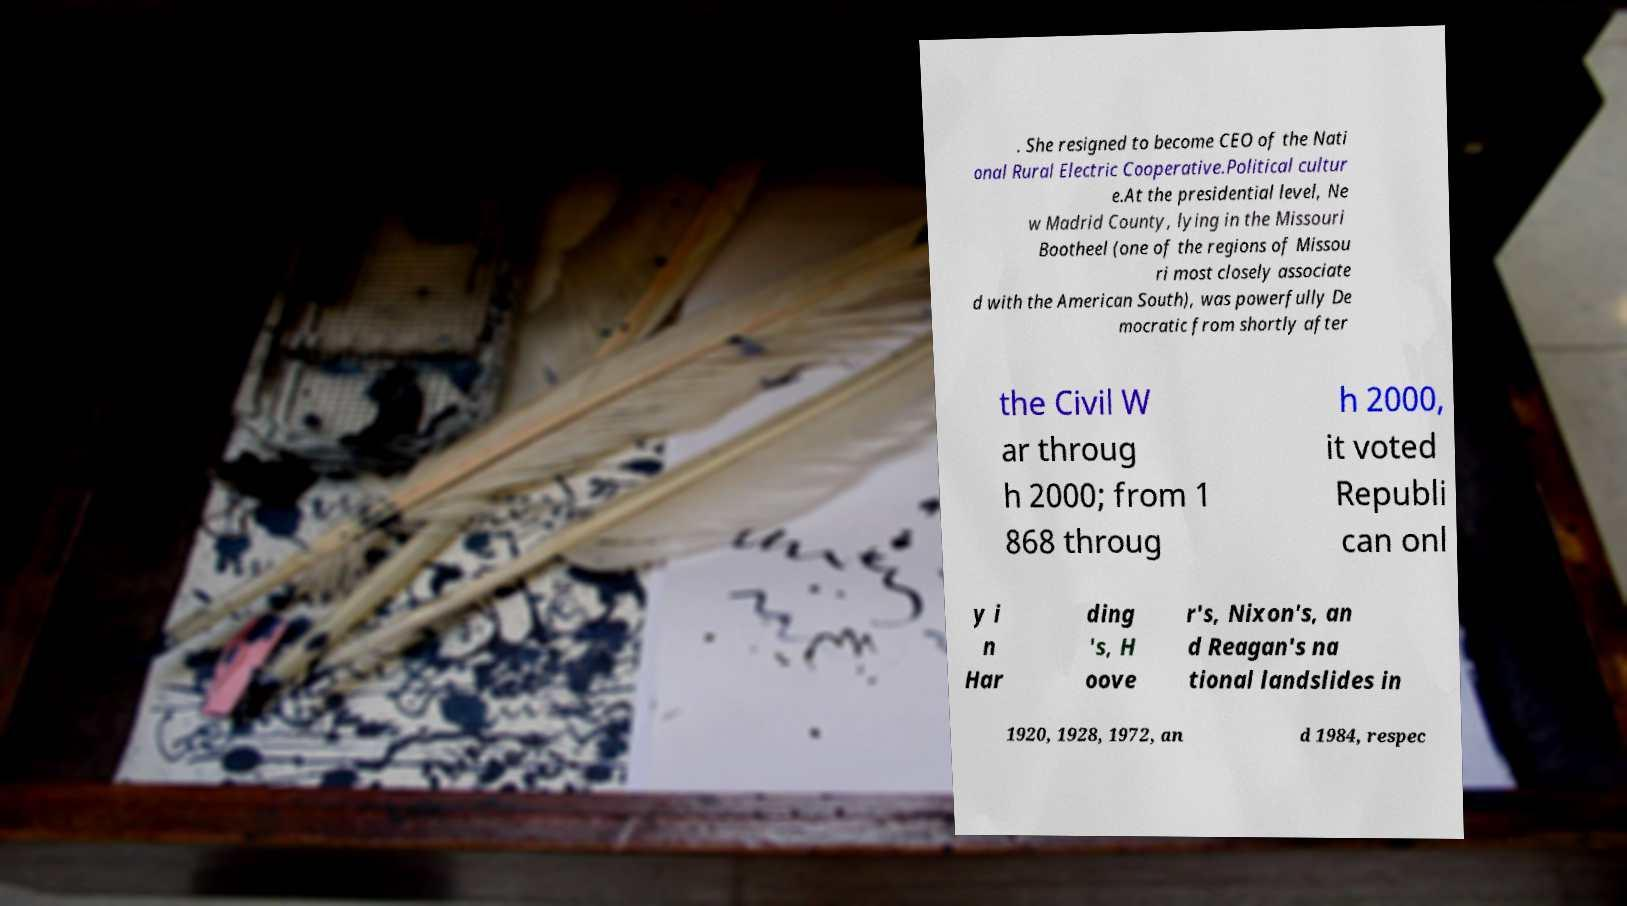Please read and relay the text visible in this image. What does it say? . She resigned to become CEO of the Nati onal Rural Electric Cooperative.Political cultur e.At the presidential level, Ne w Madrid County, lying in the Missouri Bootheel (one of the regions of Missou ri most closely associate d with the American South), was powerfully De mocratic from shortly after the Civil W ar throug h 2000; from 1 868 throug h 2000, it voted Republi can onl y i n Har ding 's, H oove r's, Nixon's, an d Reagan's na tional landslides in 1920, 1928, 1972, an d 1984, respec 